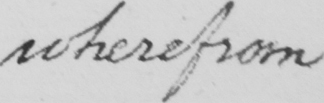What text is written in this handwritten line? wherefrom 